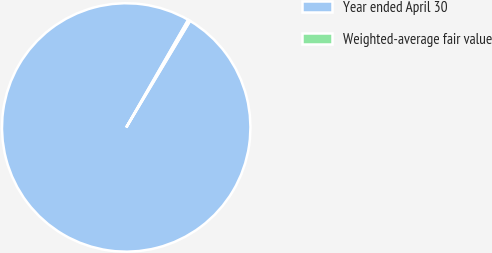Convert chart. <chart><loc_0><loc_0><loc_500><loc_500><pie_chart><fcel>Year ended April 30<fcel>Weighted-average fair value<nl><fcel>99.72%<fcel>0.28%<nl></chart> 